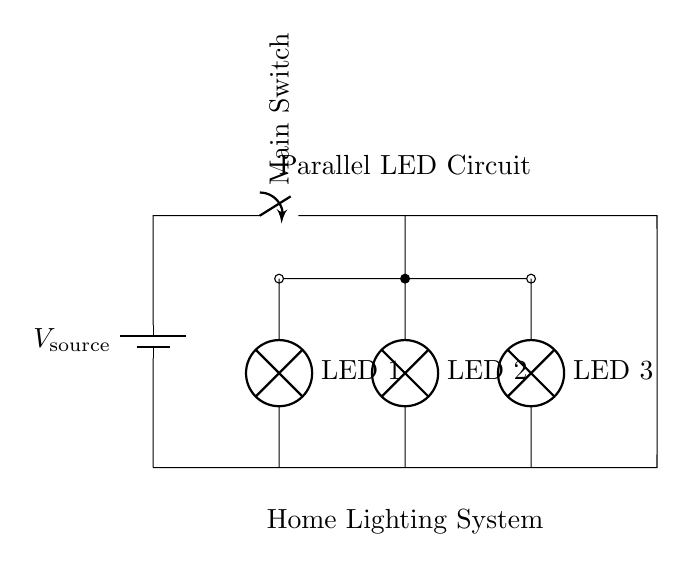What is the voltage source in this circuit? The voltage source is represented at the top left of the circuit diagram. It's labeled as V source.
Answer: V source How many LED bulbs are there? Counting the components in the diagram, there are three LED bulbs connected in parallel.
Answer: Three Which components are in parallel? The LED bulbs, labeled LED 1, LED 2, and LED 3, are connected to the same nodes, making them parallel to each other.
Answer: LED 1, LED 2, LED 3 What happens if one LED bulb fails? In a parallel circuit, if one component fails (like one LED), the other components continue to function because they have separate paths for current.
Answer: The other LEDs remain lit What is the advantage of using parallel circuits for LED bulbs? Parallel circuits allow each component to operate independently, meaning that the failure of one does not affect the others, resulting in higher reliability for the lighting system.
Answer: Higher reliability What connects all the LED bulbs? The bottom wire connects LED 1, LED 2, and LED 3, allowing the current to flow back to the source after passing through each LED.
Answer: Bottom wire How does the current behave in this circuit? In a parallel circuit, the total current from the source is divided among all branches according to their resistances, causing each LED to receive the same voltage but different current based on its resistance.
Answer: Divided among branches 